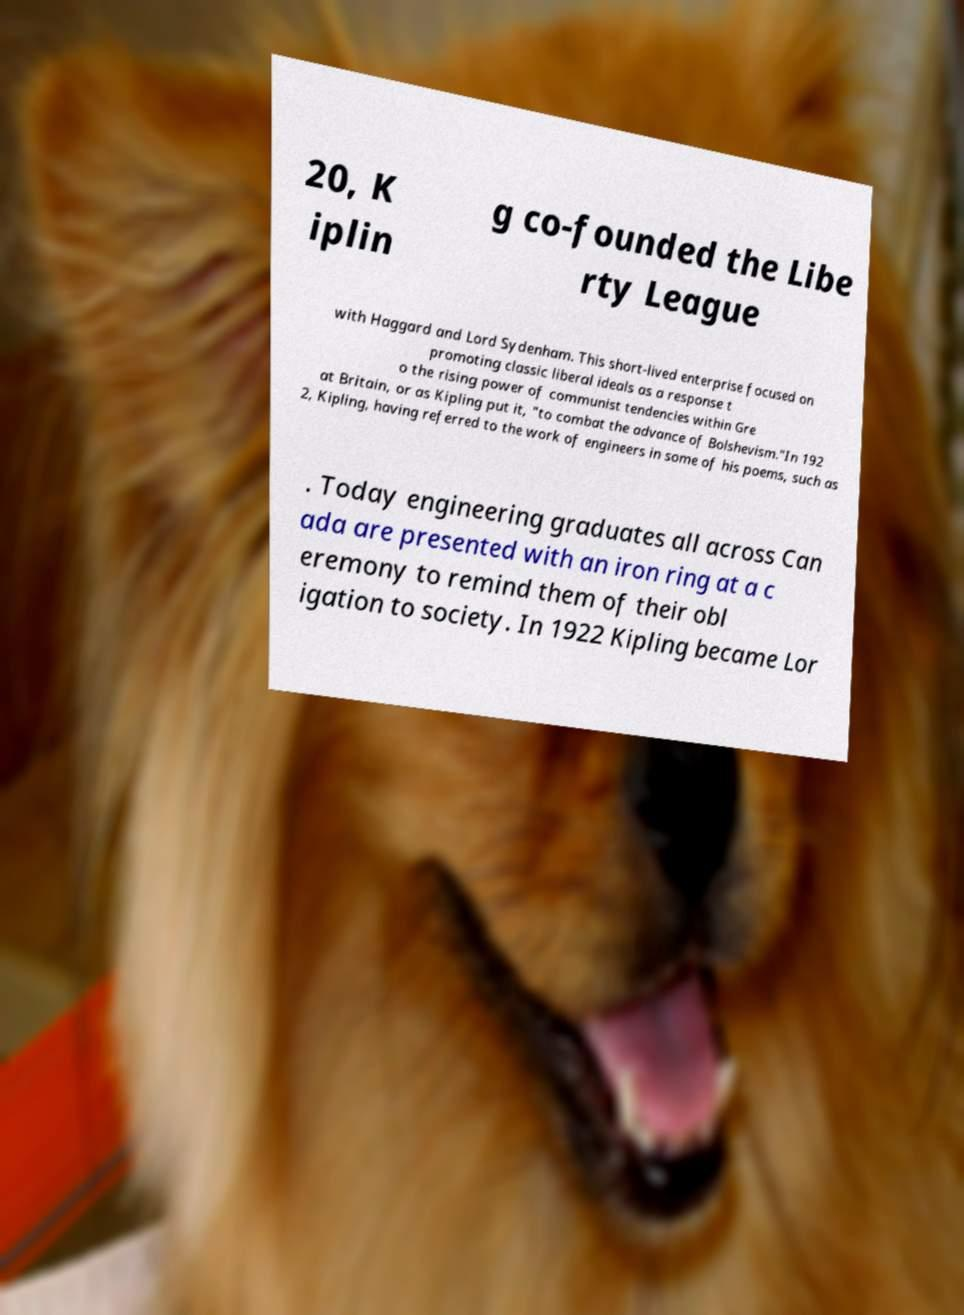Can you read and provide the text displayed in the image?This photo seems to have some interesting text. Can you extract and type it out for me? 20, K iplin g co-founded the Libe rty League with Haggard and Lord Sydenham. This short-lived enterprise focused on promoting classic liberal ideals as a response t o the rising power of communist tendencies within Gre at Britain, or as Kipling put it, "to combat the advance of Bolshevism."In 192 2, Kipling, having referred to the work of engineers in some of his poems, such as . Today engineering graduates all across Can ada are presented with an iron ring at a c eremony to remind them of their obl igation to society. In 1922 Kipling became Lor 